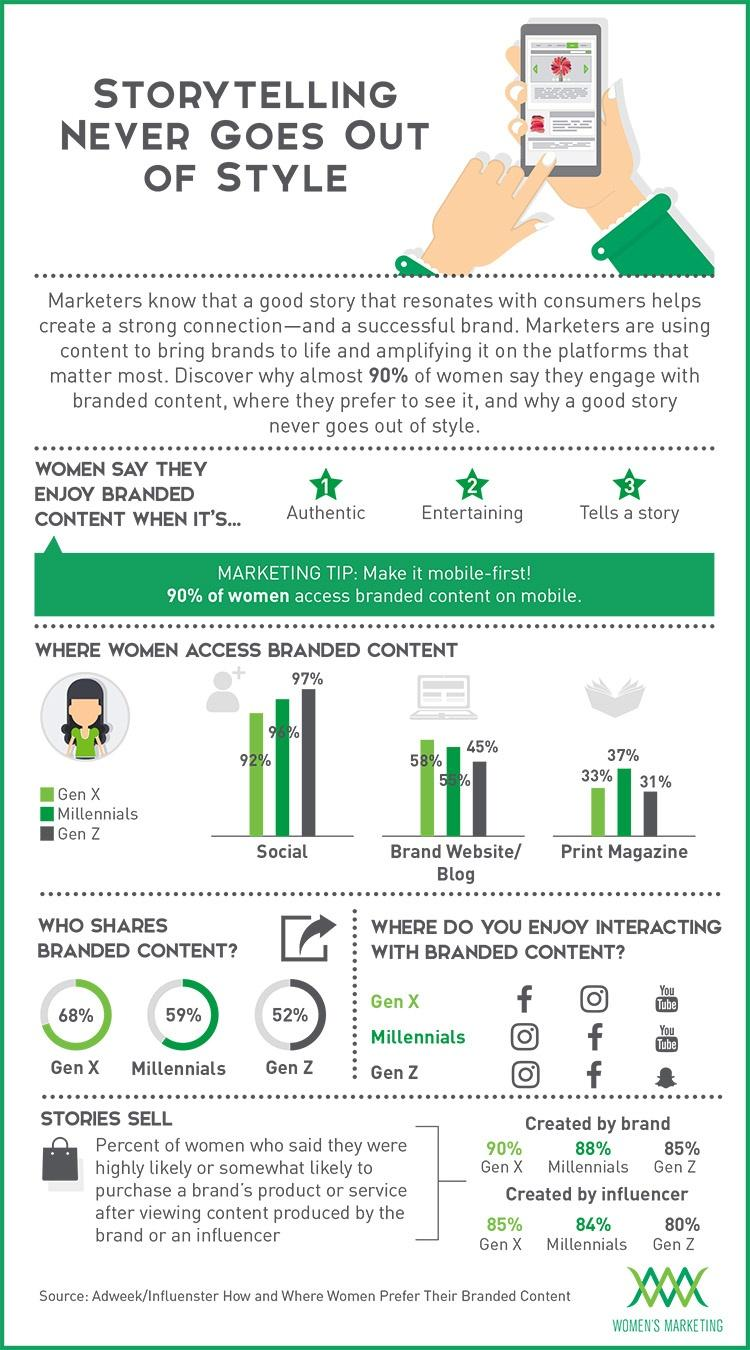Mention a couple of crucial points in this snapshot. Gen Z women primarily access branded content through social media, with a significant portion also accessing it through brand websites and print magazines. Facebook is the second most preferred social media tool among Gen Z and Millennials, followed by Instagram and YouTube. It is Gen X who uses social media the least, followed by millennials and Gen Z. According to the data, 84% of Millennial women were influenced by brand stories created by influencers and went on to buy products as a result. Thirty-three percent of Gen X individuals are accessing print magazines. 